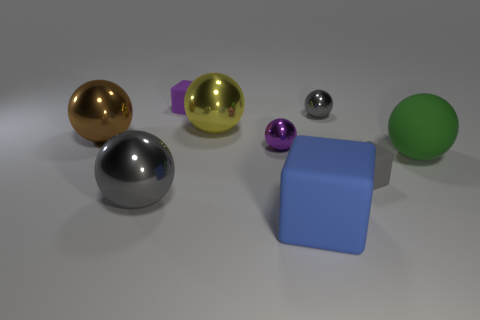Subtract all small purple cubes. How many cubes are left? 2 Subtract all cyan cylinders. How many gray spheres are left? 2 Subtract all green balls. How many balls are left? 5 Add 1 big red rubber cylinders. How many objects exist? 10 Subtract all cubes. How many objects are left? 6 Subtract all large yellow rubber blocks. Subtract all big gray balls. How many objects are left? 8 Add 3 large matte blocks. How many large matte blocks are left? 4 Add 2 shiny spheres. How many shiny spheres exist? 7 Subtract 0 red blocks. How many objects are left? 9 Subtract all green blocks. Subtract all red balls. How many blocks are left? 3 